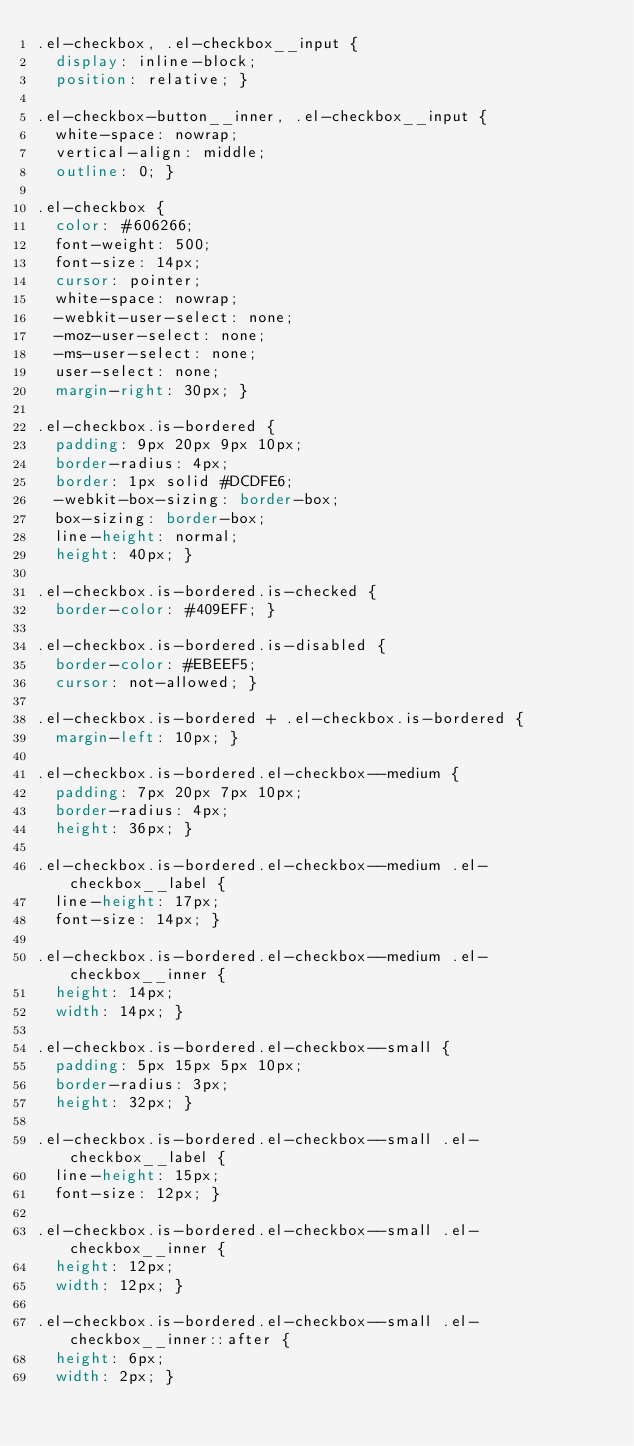<code> <loc_0><loc_0><loc_500><loc_500><_CSS_>.el-checkbox, .el-checkbox__input {
  display: inline-block;
  position: relative; }

.el-checkbox-button__inner, .el-checkbox__input {
  white-space: nowrap;
  vertical-align: middle;
  outline: 0; }

.el-checkbox {
  color: #606266;
  font-weight: 500;
  font-size: 14px;
  cursor: pointer;
  white-space: nowrap;
  -webkit-user-select: none;
  -moz-user-select: none;
  -ms-user-select: none;
  user-select: none;
  margin-right: 30px; }

.el-checkbox.is-bordered {
  padding: 9px 20px 9px 10px;
  border-radius: 4px;
  border: 1px solid #DCDFE6;
  -webkit-box-sizing: border-box;
  box-sizing: border-box;
  line-height: normal;
  height: 40px; }

.el-checkbox.is-bordered.is-checked {
  border-color: #409EFF; }

.el-checkbox.is-bordered.is-disabled {
  border-color: #EBEEF5;
  cursor: not-allowed; }

.el-checkbox.is-bordered + .el-checkbox.is-bordered {
  margin-left: 10px; }

.el-checkbox.is-bordered.el-checkbox--medium {
  padding: 7px 20px 7px 10px;
  border-radius: 4px;
  height: 36px; }

.el-checkbox.is-bordered.el-checkbox--medium .el-checkbox__label {
  line-height: 17px;
  font-size: 14px; }

.el-checkbox.is-bordered.el-checkbox--medium .el-checkbox__inner {
  height: 14px;
  width: 14px; }

.el-checkbox.is-bordered.el-checkbox--small {
  padding: 5px 15px 5px 10px;
  border-radius: 3px;
  height: 32px; }

.el-checkbox.is-bordered.el-checkbox--small .el-checkbox__label {
  line-height: 15px;
  font-size: 12px; }

.el-checkbox.is-bordered.el-checkbox--small .el-checkbox__inner {
  height: 12px;
  width: 12px; }

.el-checkbox.is-bordered.el-checkbox--small .el-checkbox__inner::after {
  height: 6px;
  width: 2px; }
</code> 